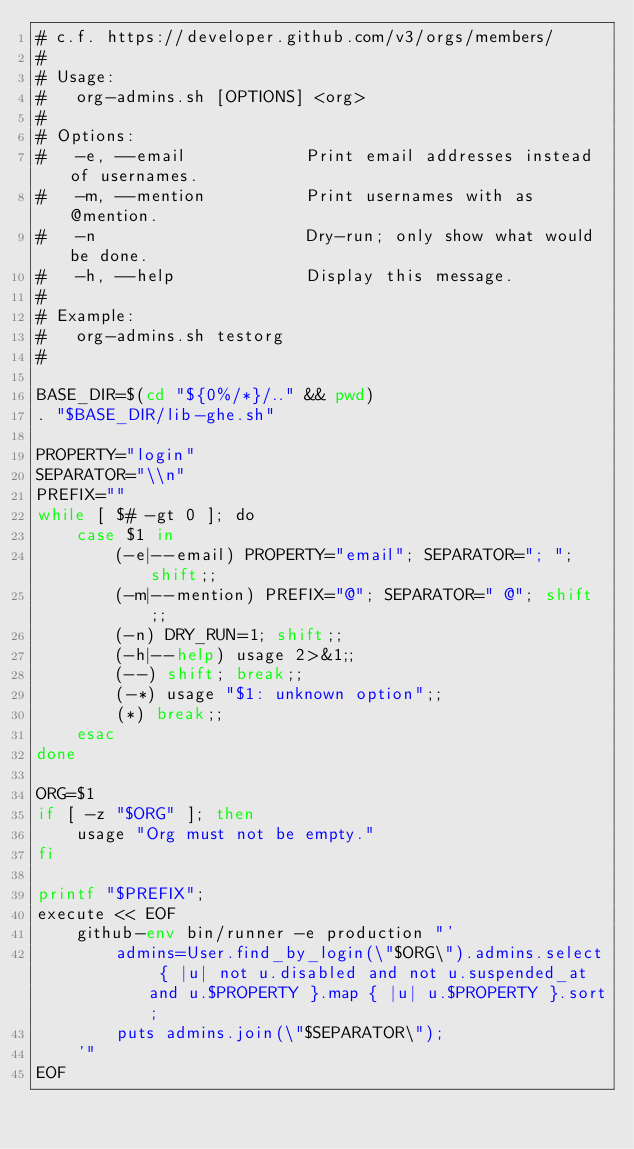<code> <loc_0><loc_0><loc_500><loc_500><_Bash_># c.f. https://developer.github.com/v3/orgs/members/
#
# Usage:
#   org-admins.sh [OPTIONS] <org>
#
# Options:
#   -e, --email            Print email addresses instead of usernames.
#   -m, --mention          Print usernames with as @mention.
#   -n                     Dry-run; only show what would be done.
#   -h, --help             Display this message.
#
# Example:
#   org-admins.sh testorg
#

BASE_DIR=$(cd "${0%/*}/.." && pwd)
. "$BASE_DIR/lib-ghe.sh"

PROPERTY="login"
SEPARATOR="\\n"
PREFIX=""
while [ $# -gt 0 ]; do
    case $1 in
        (-e|--email) PROPERTY="email"; SEPARATOR="; "; shift;;
        (-m|--mention) PREFIX="@"; SEPARATOR=" @"; shift;;
        (-n) DRY_RUN=1; shift;;
        (-h|--help) usage 2>&1;;
        (--) shift; break;;
        (-*) usage "$1: unknown option";;
        (*) break;;
    esac
done

ORG=$1
if [ -z "$ORG" ]; then
    usage "Org must not be empty."
fi

printf "$PREFIX";
execute << EOF
    github-env bin/runner -e production "'
        admins=User.find_by_login(\"$ORG\").admins.select { |u| not u.disabled and not u.suspended_at and u.$PROPERTY }.map { |u| u.$PROPERTY }.sort;
        puts admins.join(\"$SEPARATOR\");
    '"
EOF
</code> 